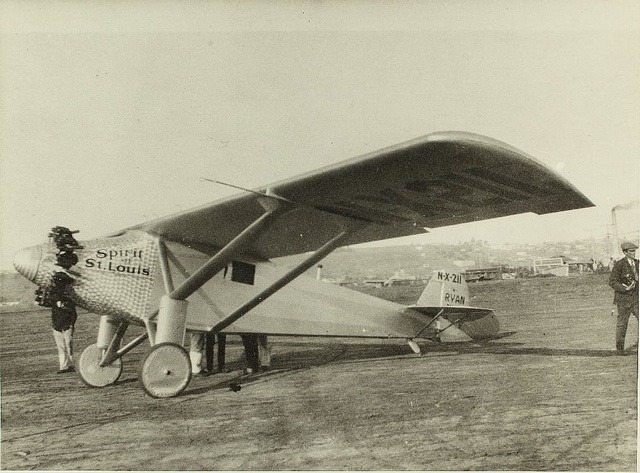Describe the objects in this image and their specific colors. I can see airplane in beige, darkgray, black, and gray tones, people in beige, gray, black, and darkgray tones, people in beige, black, gray, and darkgray tones, people in beige, black, and gray tones, and people in beige, black, and gray tones in this image. 